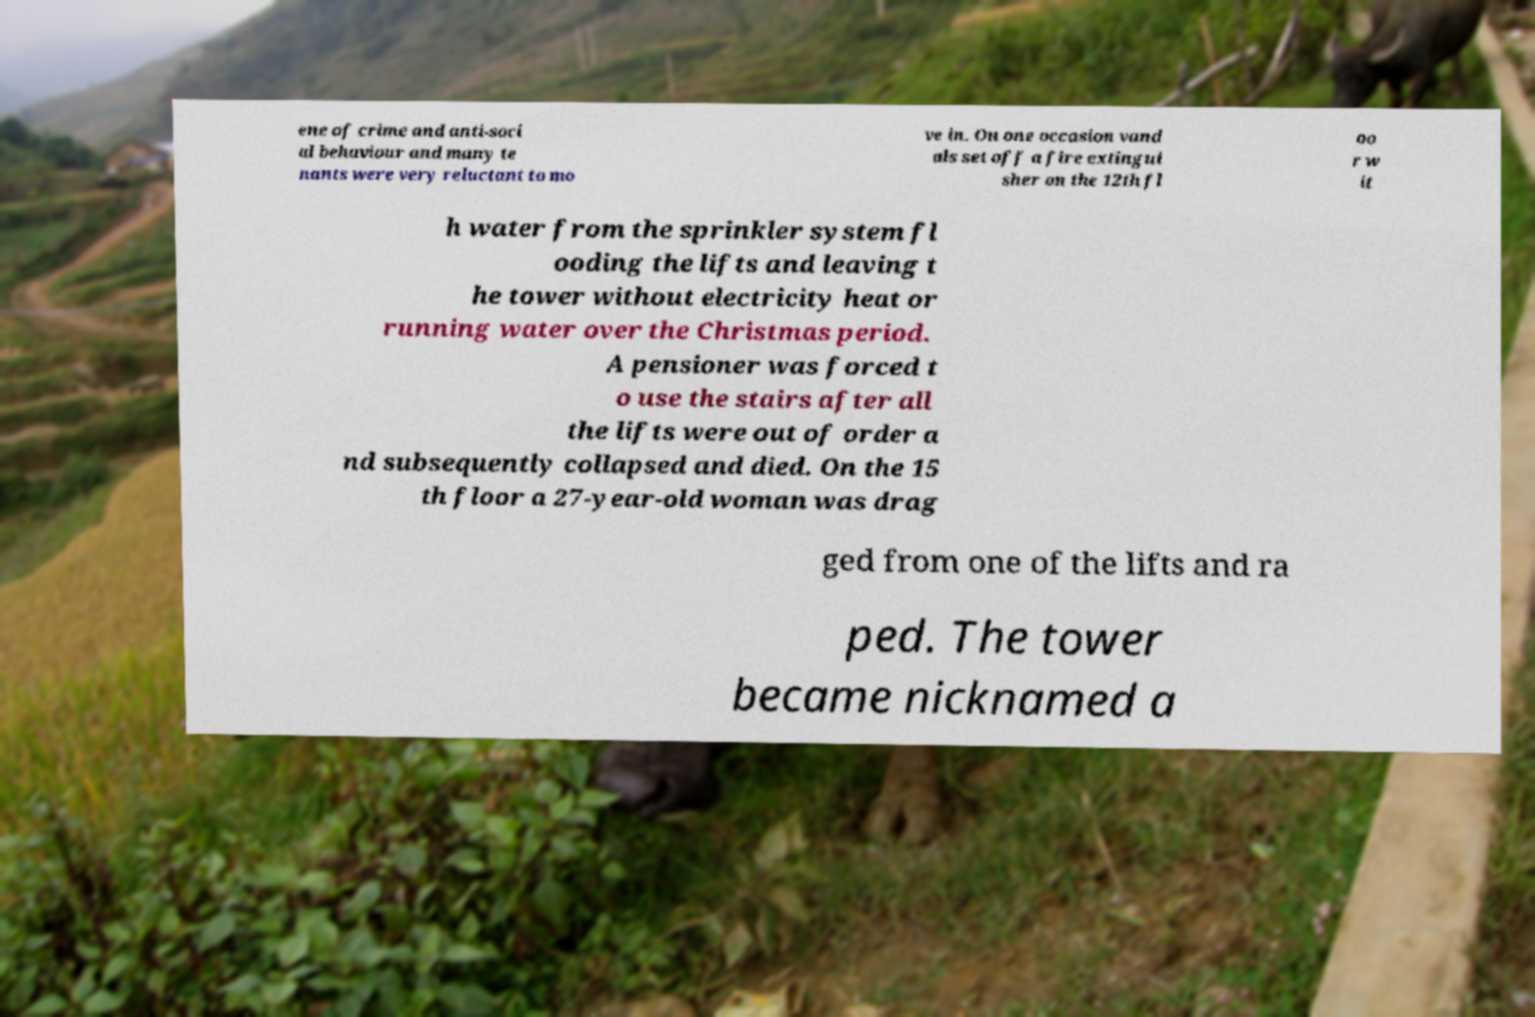Please read and relay the text visible in this image. What does it say? ene of crime and anti-soci al behaviour and many te nants were very reluctant to mo ve in. On one occasion vand als set off a fire extingui sher on the 12th fl oo r w it h water from the sprinkler system fl ooding the lifts and leaving t he tower without electricity heat or running water over the Christmas period. A pensioner was forced t o use the stairs after all the lifts were out of order a nd subsequently collapsed and died. On the 15 th floor a 27-year-old woman was drag ged from one of the lifts and ra ped. The tower became nicknamed a 